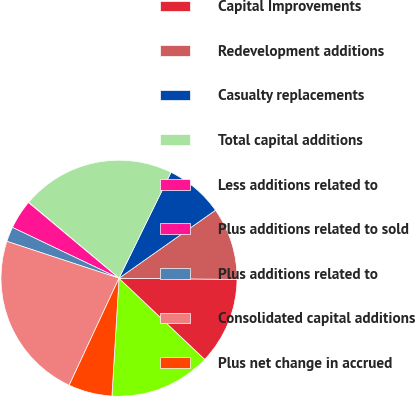Convert chart to OTSL. <chart><loc_0><loc_0><loc_500><loc_500><pie_chart><fcel>Capital Replacements<fcel>Capital Improvements<fcel>Redevelopment additions<fcel>Casualty replacements<fcel>Total capital additions<fcel>Less additions related to<fcel>Plus additions related to sold<fcel>Plus additions related to<fcel>Consolidated capital additions<fcel>Plus net change in accrued<nl><fcel>13.89%<fcel>11.91%<fcel>9.93%<fcel>7.96%<fcel>21.14%<fcel>0.04%<fcel>4.0%<fcel>2.02%<fcel>23.12%<fcel>5.98%<nl></chart> 